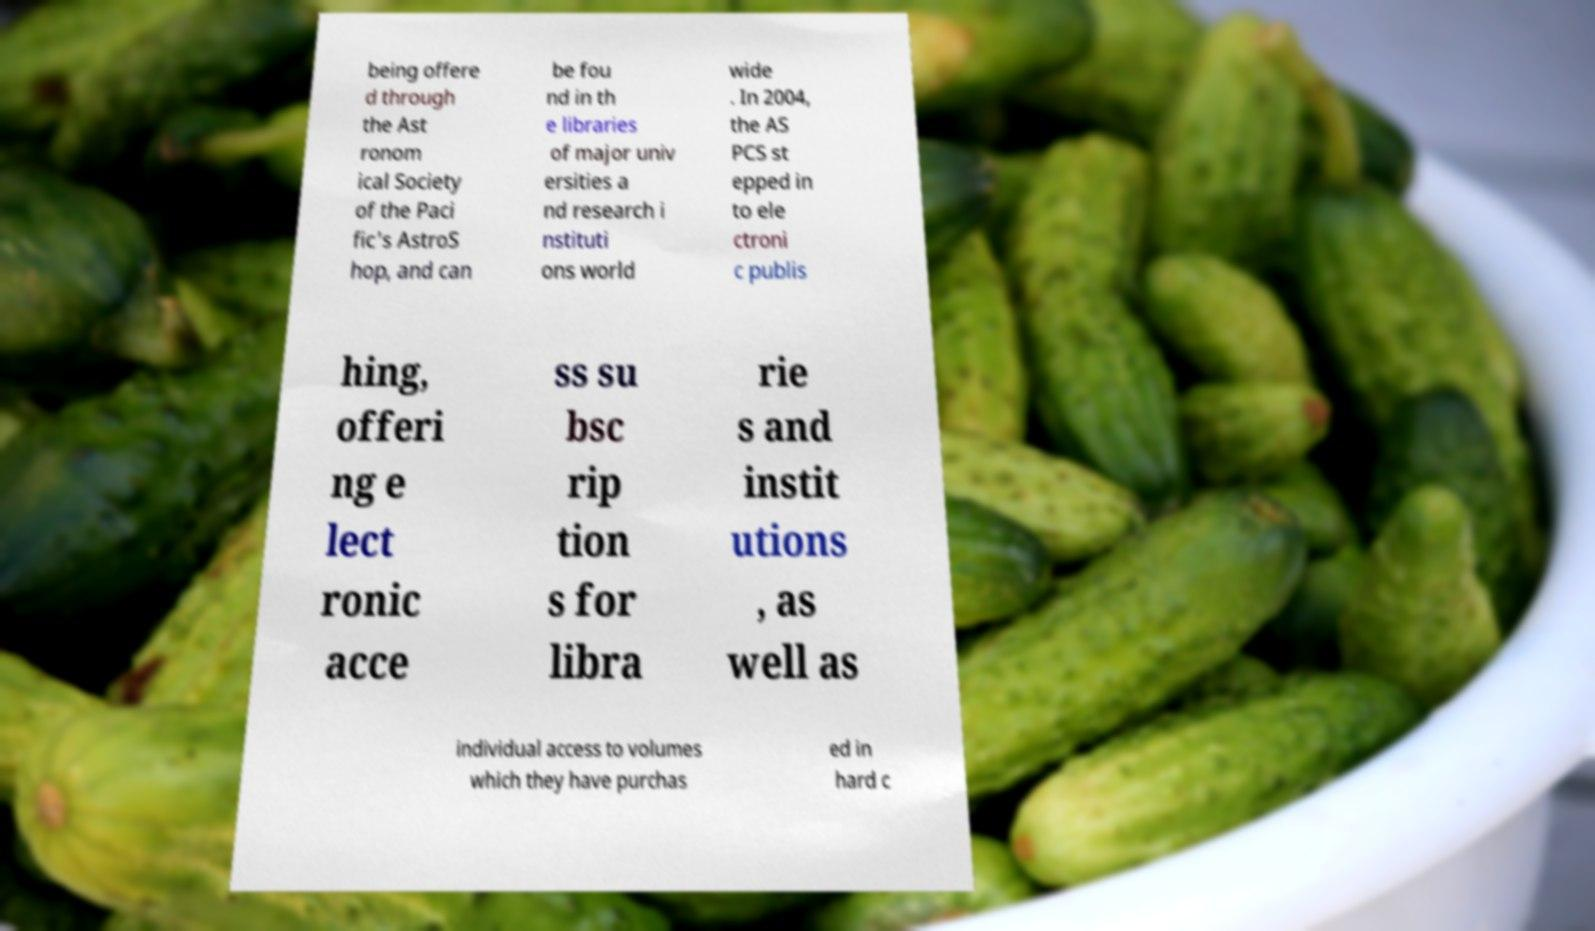Can you read and provide the text displayed in the image?This photo seems to have some interesting text. Can you extract and type it out for me? being offere d through the Ast ronom ical Society of the Paci fic's AstroS hop, and can be fou nd in th e libraries of major univ ersities a nd research i nstituti ons world wide . In 2004, the AS PCS st epped in to ele ctroni c publis hing, offeri ng e lect ronic acce ss su bsc rip tion s for libra rie s and instit utions , as well as individual access to volumes which they have purchas ed in hard c 